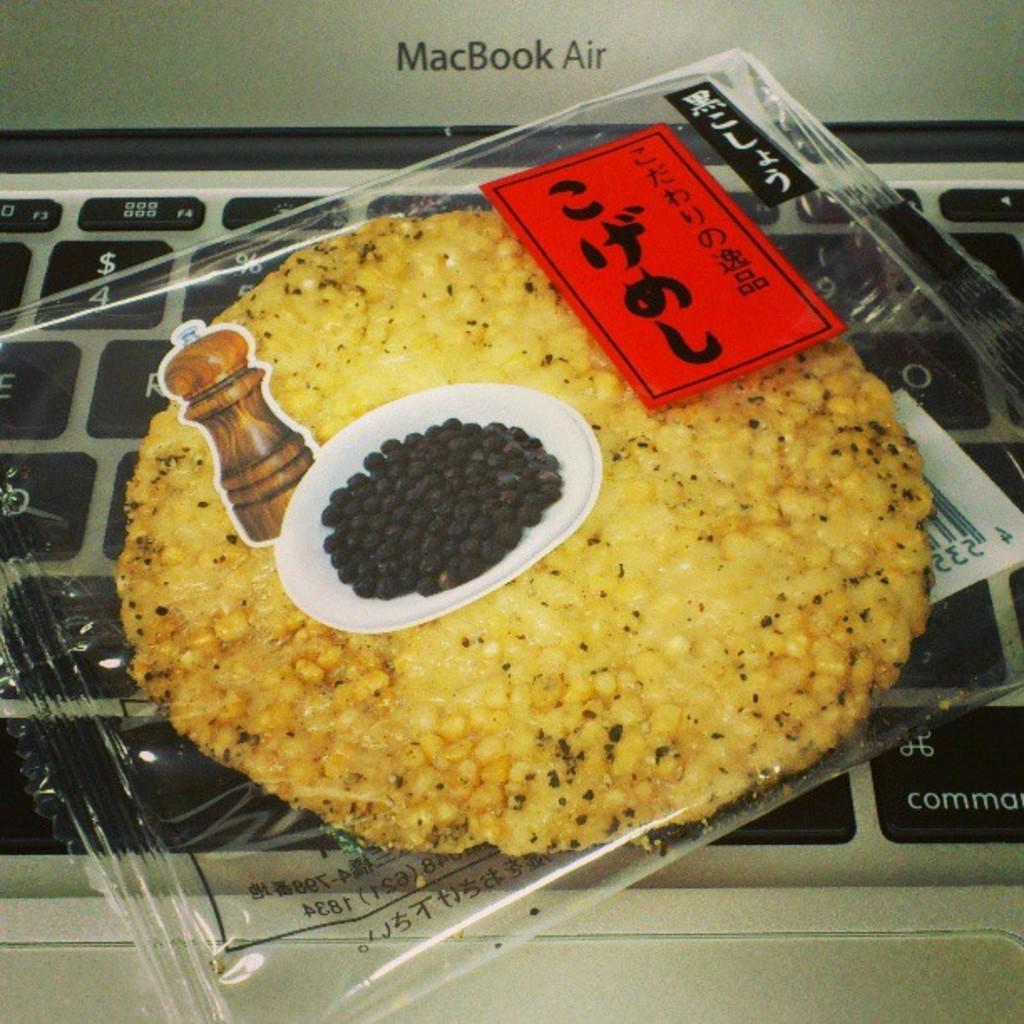Please provide a concise description of this image. In this image there is food inside the cover, there are stickers on the cover, at the background of the image there is a laptop truncated. 